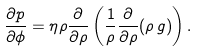<formula> <loc_0><loc_0><loc_500><loc_500>\frac { \partial p } { \partial \phi } = \eta \rho \frac { \partial } { \partial \rho } \left ( \frac { 1 } { \rho } \frac { \partial } { \partial \rho } ( \rho \, g ) \right ) .</formula> 